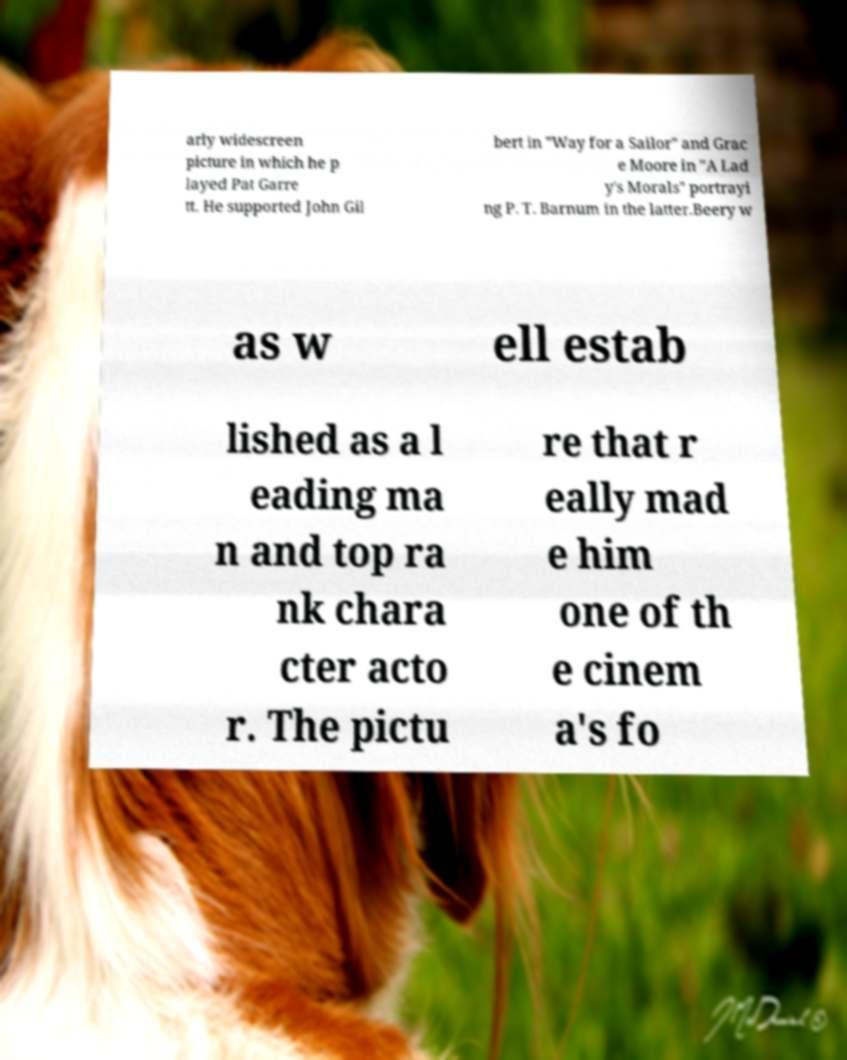I need the written content from this picture converted into text. Can you do that? arly widescreen picture in which he p layed Pat Garre tt. He supported John Gil bert in "Way for a Sailor" and Grac e Moore in "A Lad y's Morals" portrayi ng P. T. Barnum in the latter.Beery w as w ell estab lished as a l eading ma n and top ra nk chara cter acto r. The pictu re that r eally mad e him one of th e cinem a's fo 